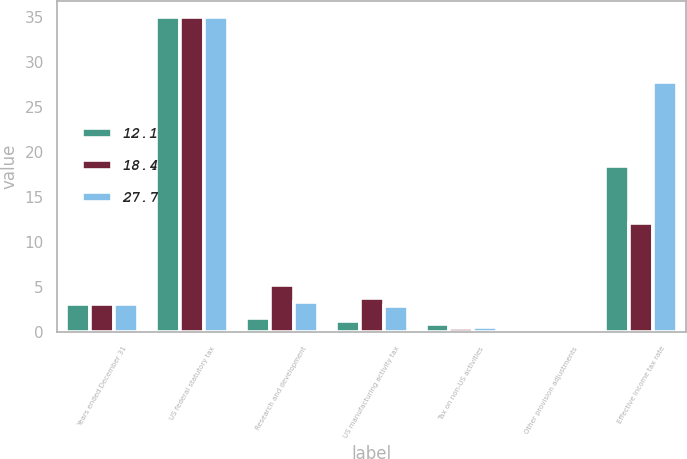<chart> <loc_0><loc_0><loc_500><loc_500><stacked_bar_chart><ecel><fcel>Years ended December 31<fcel>US federal statutory tax<fcel>Research and development<fcel>US manufacturing activity tax<fcel>Tax on non-US activities<fcel>Other provision adjustments<fcel>Effective income tax rate<nl><fcel>12.1<fcel>3.15<fcel>35<fcel>1.6<fcel>1.3<fcel>0.9<fcel>0.2<fcel>18.4<nl><fcel>18.4<fcel>3.15<fcel>35<fcel>5.2<fcel>3.8<fcel>0.5<fcel>0.4<fcel>12.1<nl><fcel>27.7<fcel>3.15<fcel>35<fcel>3.4<fcel>2.9<fcel>0.6<fcel>0.4<fcel>27.7<nl></chart> 